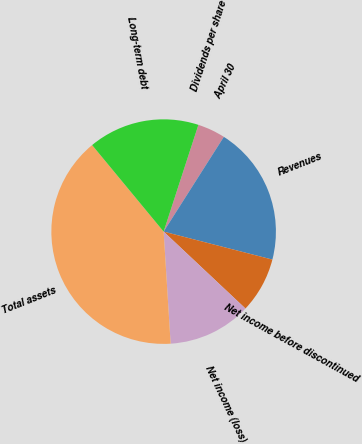Convert chart to OTSL. <chart><loc_0><loc_0><loc_500><loc_500><pie_chart><fcel>April 30<fcel>Revenues<fcel>Net income before discontinued<fcel>Net income (loss)<fcel>Total assets<fcel>Long-term debt<fcel>Dividends per share<nl><fcel>4.0%<fcel>20.0%<fcel>8.0%<fcel>12.0%<fcel>40.0%<fcel>16.0%<fcel>0.0%<nl></chart> 